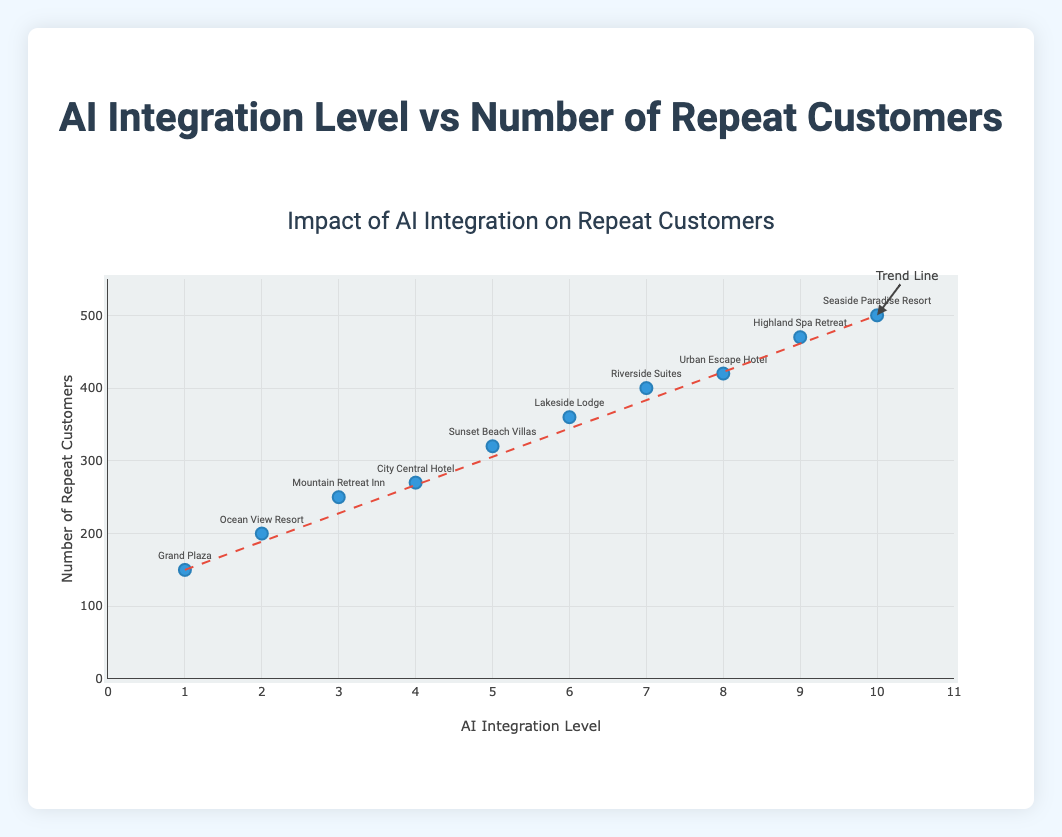What does the title of the figure indicate? The title of the figure is "AI Integration Level vs Number of Repeat Customers." It indicates that the plot is about examining the relationship between the level of AI integration in hotels and the number of repeat customers they have.
Answer: AI Integration Level vs Number of Repeat Customers How many data points are there, and what do they represent? There are 10 data points on the scatter plot, each representing a hotel with its AI Integration Level on the x-axis and its Number of Repeat Customers on the y-axis.
Answer: 10 data points representing hotels What is the range of AI Integration Level on the x-axis? The x-axis ranges from 0 to 11, as shown by the axis ticks and labels.
Answer: 0 to 11 Which hotel has the highest number of repeat customers, and what is its AI Integration Level? "Seaside Paradise Resort" has the highest number of repeat customers at 500, and its AI Integration Level is 10.
Answer: Seaside Paradise Resort, AI Level 10 What is the relationship between AI Integration Level and Number of Repeat Customers shown by the trend line? The trend line indicates a positive relationship, showing that as the AI Integration Level increases, the Number of Repeat Customers also increases.
Answer: Positive relationship What is the difference in the number of repeat customers between "Grand Plaza" and "Sunset Beach Villas"? "Grand Plaza" has 150 repeat customers while "Sunset Beach Villas" has 320 repeat customers. The difference is 320 - 150 = 170.
Answer: 170 Which hotel has the smallest number of repeat customers, and what is its AI Integration Level? "Grand Plaza" has the smallest number of repeat customers at 150, with an AI Integration Level of 1.
Answer: Grand Plaza, AI Level 1 How much does the Number of Repeat Customers increase, on average, with each increase in AI Integration Level? The Number of Repeat Customers increases from 150 at an AI Integration Level of 1 to 500 at an AI Integration Level of 10. The total increase is 500 - 150 = 350 over 9 levels. The average increase per level is 350 / 9 ≈ 38.89.
Answer: ≈ 38.89 Which data point is closest to the trend line originally drawn from (1, 150) to (10, 500)? "City Central Hotel" at AI Integration Level 4 and 270 repeat customers appears to be closest to the trend line. The trend line at AI Level 4 approximates to 277.78 customers.
Answer: City Central Hotel Is there any data point that significantly deviates from the trend line? No, all data points lie close to the trend line, indicating a consistent increase in repeat customers with higher AI Integration Levels.
Answer: No 